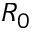<formula> <loc_0><loc_0><loc_500><loc_500>R _ { 0 }</formula> 